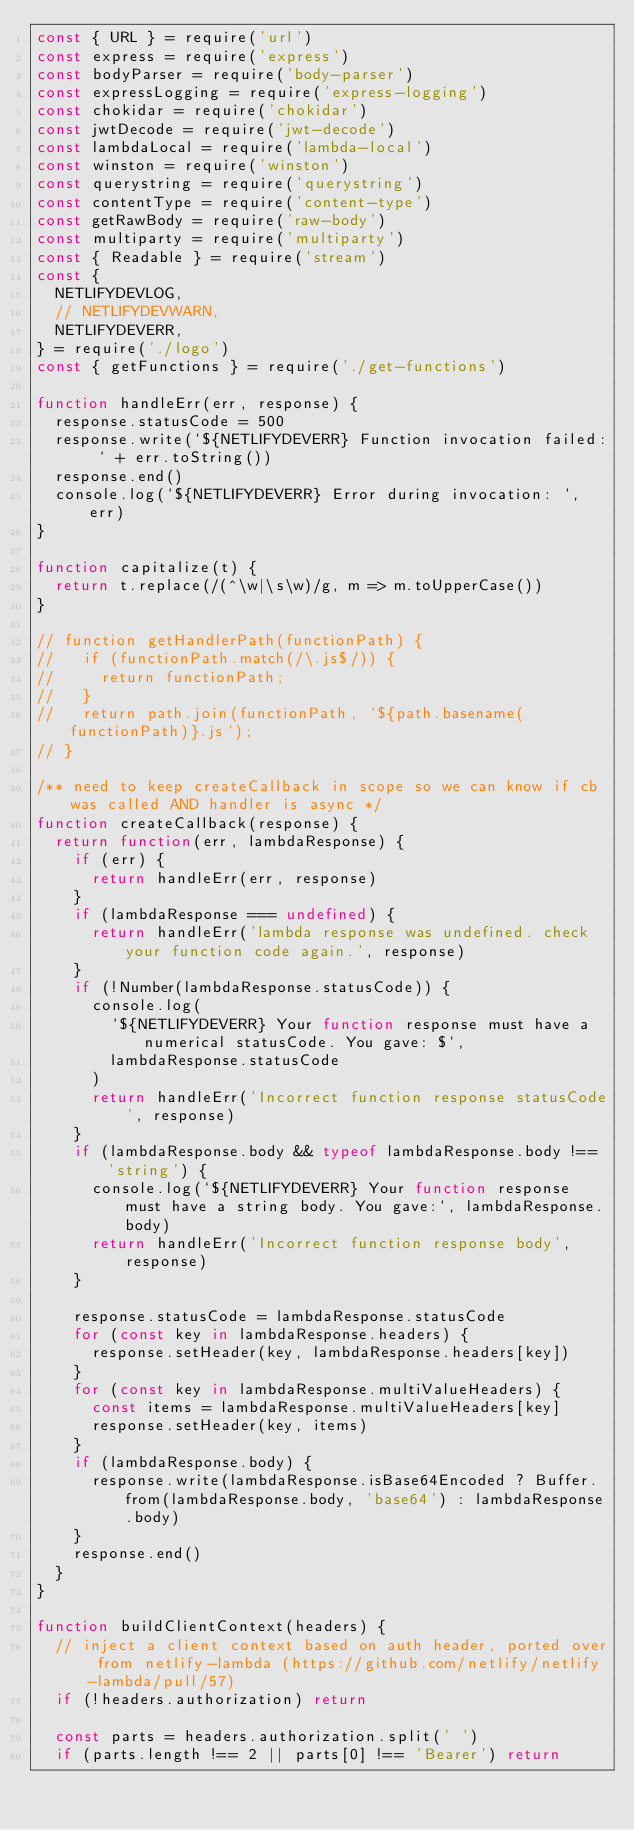<code> <loc_0><loc_0><loc_500><loc_500><_JavaScript_>const { URL } = require('url')
const express = require('express')
const bodyParser = require('body-parser')
const expressLogging = require('express-logging')
const chokidar = require('chokidar')
const jwtDecode = require('jwt-decode')
const lambdaLocal = require('lambda-local')
const winston = require('winston')
const querystring = require('querystring')
const contentType = require('content-type')
const getRawBody = require('raw-body')
const multiparty = require('multiparty')
const { Readable } = require('stream')
const {
  NETLIFYDEVLOG,
  // NETLIFYDEVWARN,
  NETLIFYDEVERR,
} = require('./logo')
const { getFunctions } = require('./get-functions')

function handleErr(err, response) {
  response.statusCode = 500
  response.write(`${NETLIFYDEVERR} Function invocation failed: ` + err.toString())
  response.end()
  console.log(`${NETLIFYDEVERR} Error during invocation: `, err)
}

function capitalize(t) {
  return t.replace(/(^\w|\s\w)/g, m => m.toUpperCase())
}

// function getHandlerPath(functionPath) {
//   if (functionPath.match(/\.js$/)) {
//     return functionPath;
//   }
//   return path.join(functionPath, `${path.basename(functionPath)}.js`);
// }

/** need to keep createCallback in scope so we can know if cb was called AND handler is async */
function createCallback(response) {
  return function(err, lambdaResponse) {
    if (err) {
      return handleErr(err, response)
    }
    if (lambdaResponse === undefined) {
      return handleErr('lambda response was undefined. check your function code again.', response)
    }
    if (!Number(lambdaResponse.statusCode)) {
      console.log(
        `${NETLIFYDEVERR} Your function response must have a numerical statusCode. You gave: $`,
        lambdaResponse.statusCode
      )
      return handleErr('Incorrect function response statusCode', response)
    }
    if (lambdaResponse.body && typeof lambdaResponse.body !== 'string') {
      console.log(`${NETLIFYDEVERR} Your function response must have a string body. You gave:`, lambdaResponse.body)
      return handleErr('Incorrect function response body', response)
    }

    response.statusCode = lambdaResponse.statusCode
    for (const key in lambdaResponse.headers) {
      response.setHeader(key, lambdaResponse.headers[key])
    }
    for (const key in lambdaResponse.multiValueHeaders) {
      const items = lambdaResponse.multiValueHeaders[key]
      response.setHeader(key, items)
    }
    if (lambdaResponse.body) {
      response.write(lambdaResponse.isBase64Encoded ? Buffer.from(lambdaResponse.body, 'base64') : lambdaResponse.body)
    }
    response.end()
  }
}

function buildClientContext(headers) {
  // inject a client context based on auth header, ported over from netlify-lambda (https://github.com/netlify/netlify-lambda/pull/57)
  if (!headers.authorization) return

  const parts = headers.authorization.split(' ')
  if (parts.length !== 2 || parts[0] !== 'Bearer') return
</code> 